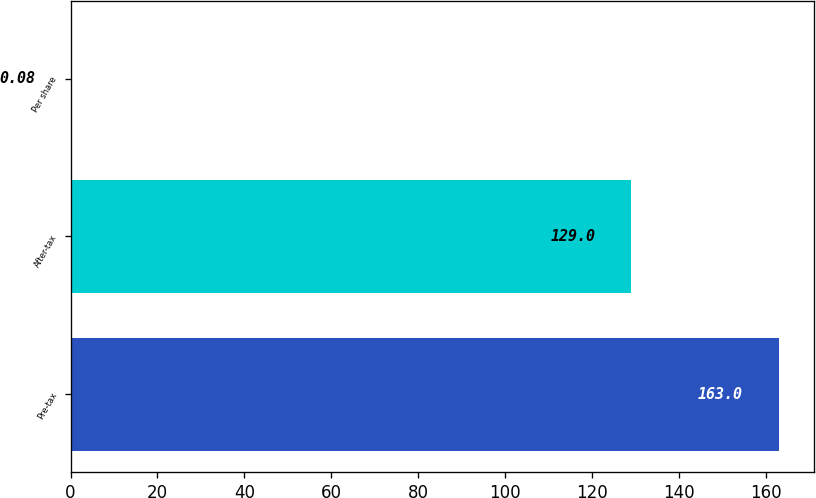Convert chart. <chart><loc_0><loc_0><loc_500><loc_500><bar_chart><fcel>Pre-tax<fcel>After-tax<fcel>Per share<nl><fcel>163<fcel>129<fcel>0.08<nl></chart> 